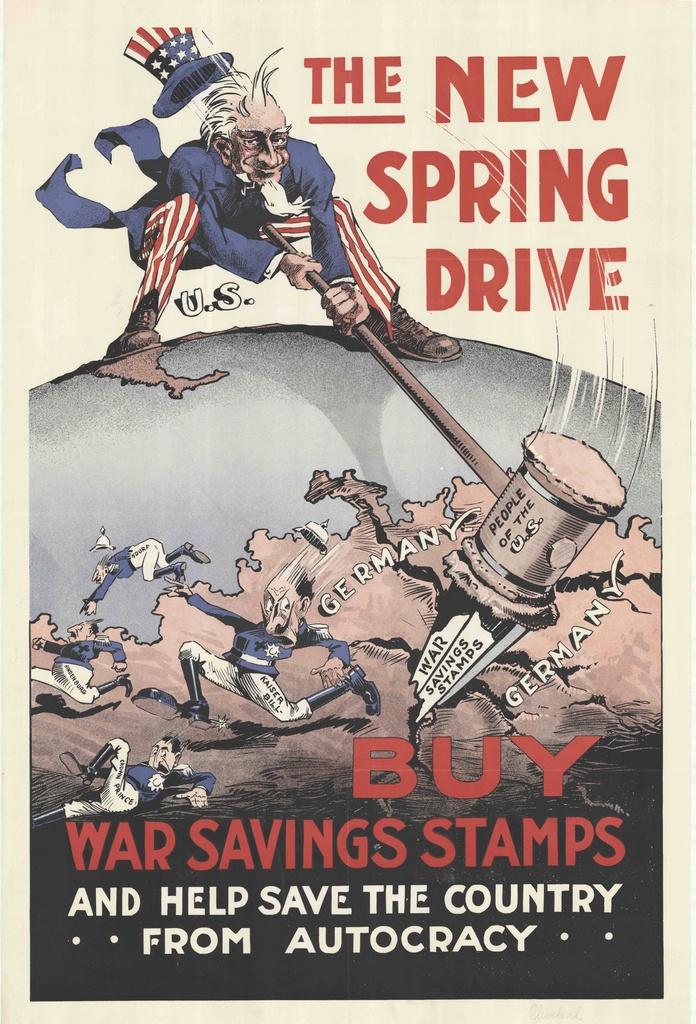What is this telling you to buy?
Make the answer very short. War saving stamps. What kind of drive is this?
Ensure brevity in your answer.  Spring. 